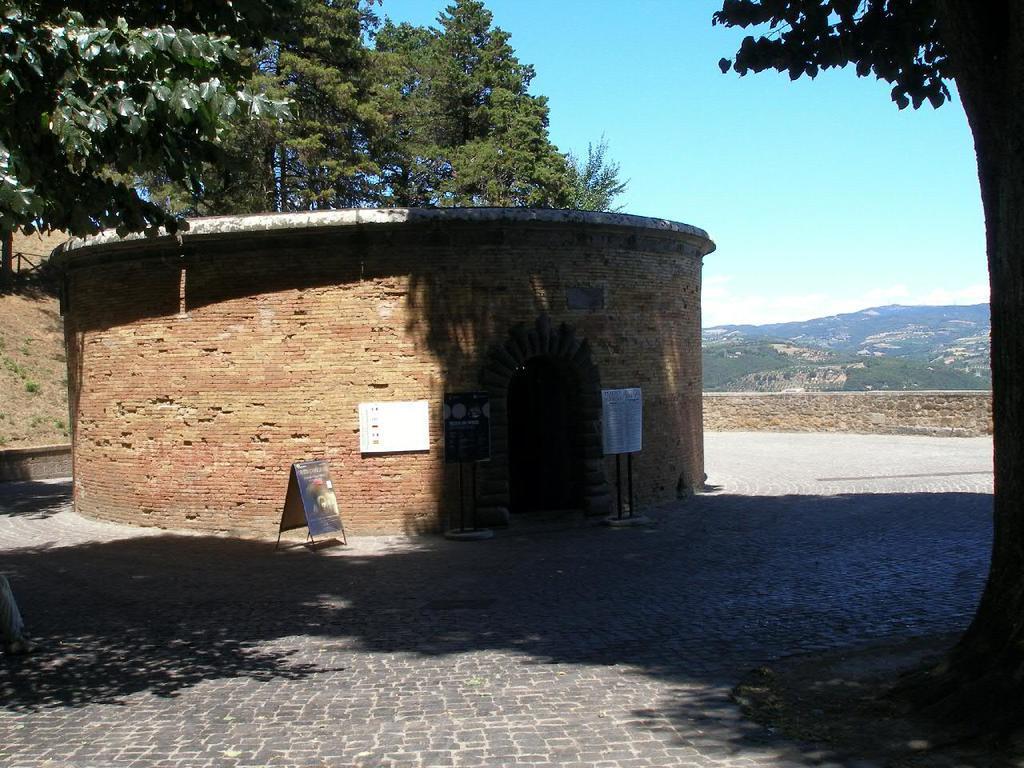Could you give a brief overview of what you see in this image? In this image we can see a building and there are some boards in front of the building and there is a wall around it. We can see some trees and mountains in the background and at the top we can see the sky. 